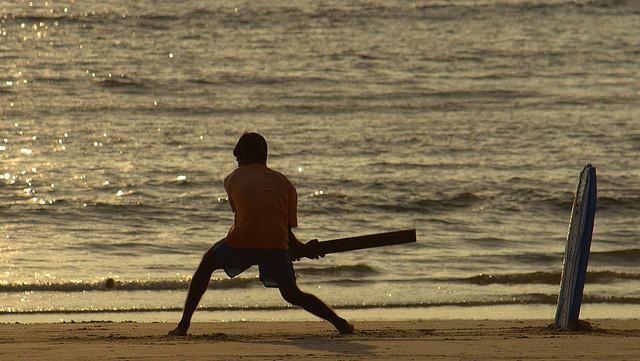How many cars are parked?
Give a very brief answer. 0. 